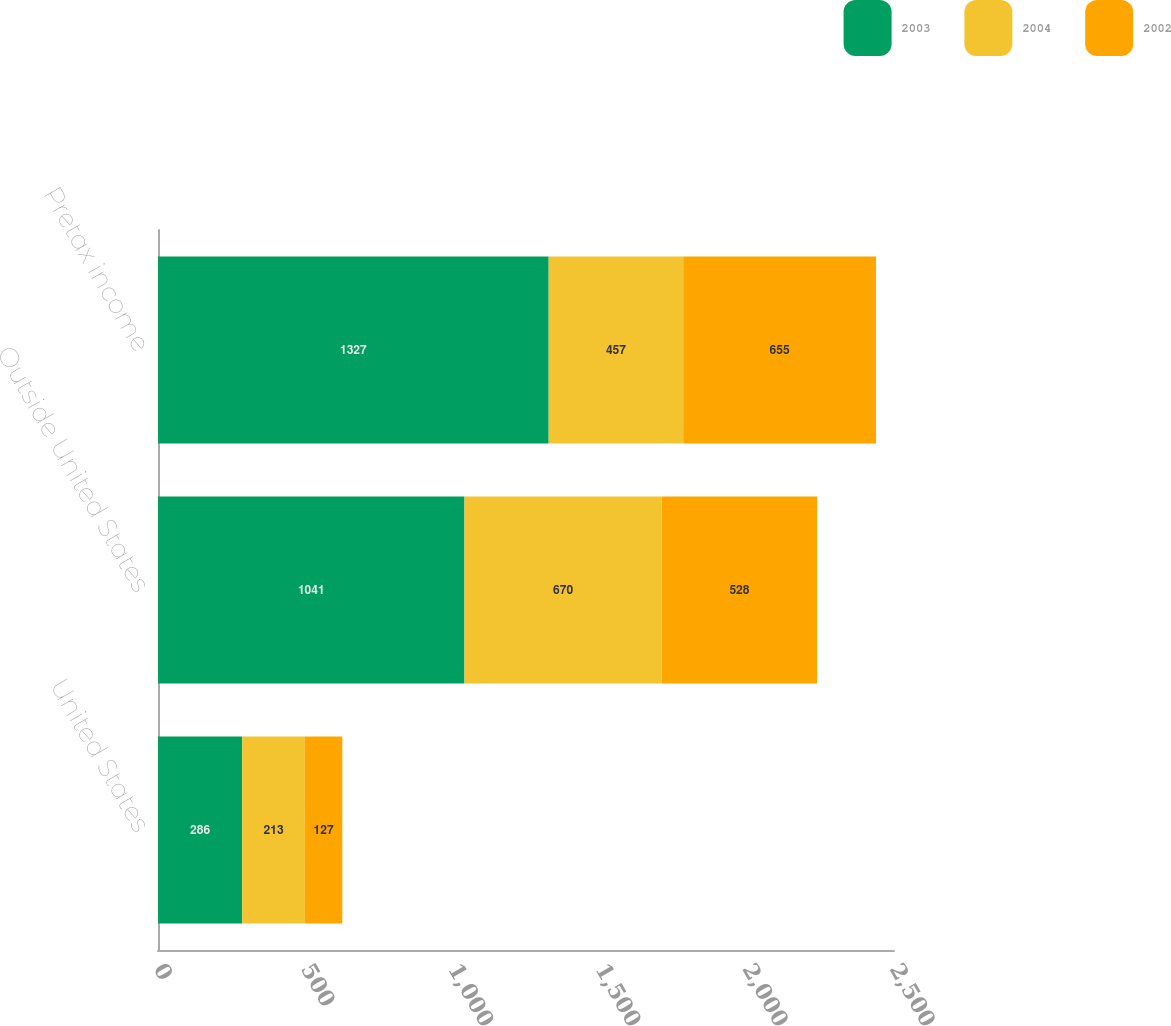Convert chart. <chart><loc_0><loc_0><loc_500><loc_500><stacked_bar_chart><ecel><fcel>United States<fcel>Outside United States<fcel>Pretax income<nl><fcel>2003<fcel>286<fcel>1041<fcel>1327<nl><fcel>2004<fcel>213<fcel>670<fcel>457<nl><fcel>2002<fcel>127<fcel>528<fcel>655<nl></chart> 